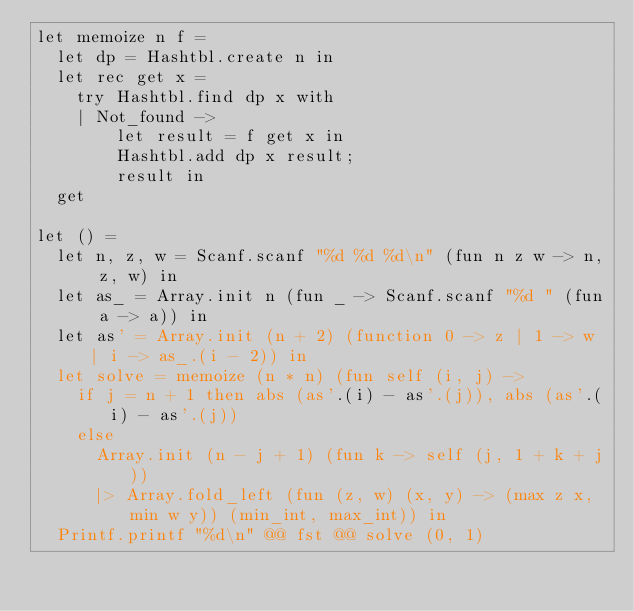Convert code to text. <code><loc_0><loc_0><loc_500><loc_500><_OCaml_>let memoize n f =
  let dp = Hashtbl.create n in
  let rec get x =
    try Hashtbl.find dp x with
    | Not_found ->
        let result = f get x in
        Hashtbl.add dp x result;
        result in
  get

let () =
  let n, z, w = Scanf.scanf "%d %d %d\n" (fun n z w -> n, z, w) in
  let as_ = Array.init n (fun _ -> Scanf.scanf "%d " (fun a -> a)) in
  let as' = Array.init (n + 2) (function 0 -> z | 1 -> w | i -> as_.(i - 2)) in
  let solve = memoize (n * n) (fun self (i, j) ->
    if j = n + 1 then abs (as'.(i) - as'.(j)), abs (as'.(i) - as'.(j))
    else
      Array.init (n - j + 1) (fun k -> self (j, 1 + k + j))
      |> Array.fold_left (fun (z, w) (x, y) -> (max z x, min w y)) (min_int, max_int)) in
  Printf.printf "%d\n" @@ fst @@ solve (0, 1)</code> 